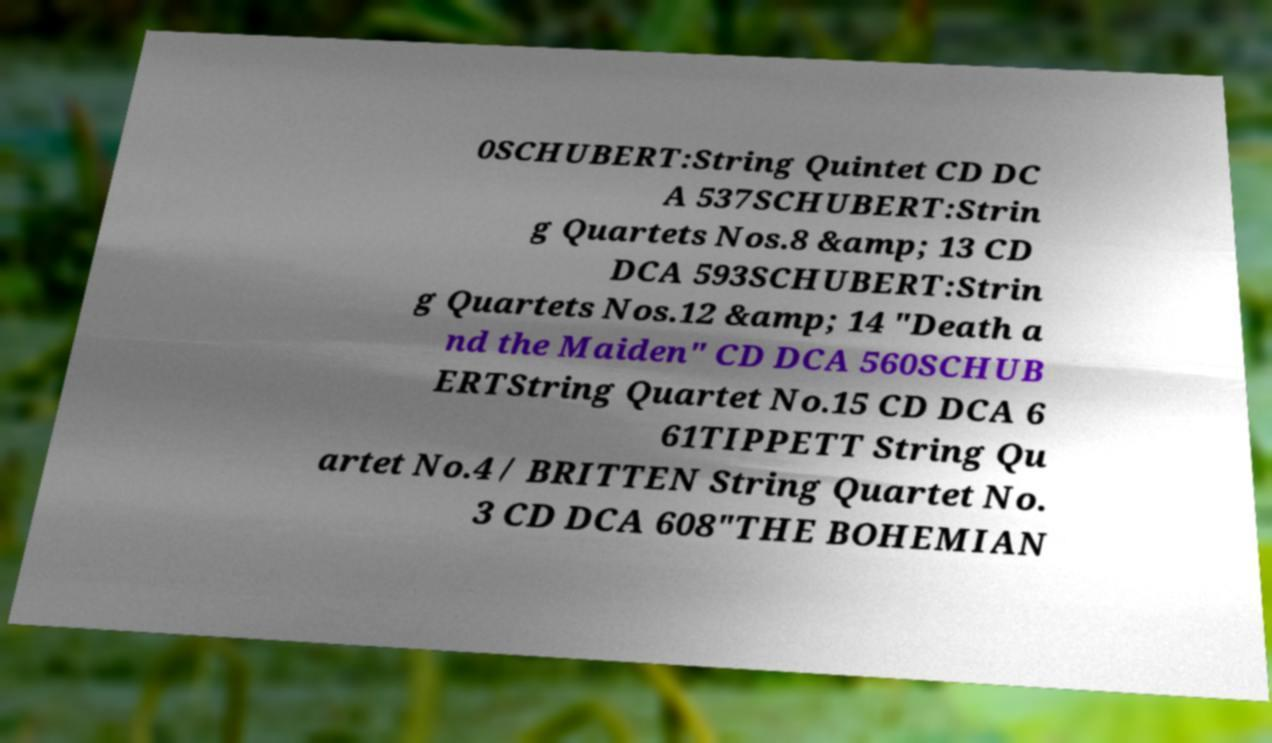Could you assist in decoding the text presented in this image and type it out clearly? 0SCHUBERT:String Quintet CD DC A 537SCHUBERT:Strin g Quartets Nos.8 &amp; 13 CD DCA 593SCHUBERT:Strin g Quartets Nos.12 &amp; 14 "Death a nd the Maiden" CD DCA 560SCHUB ERTString Quartet No.15 CD DCA 6 61TIPPETT String Qu artet No.4 / BRITTEN String Quartet No. 3 CD DCA 608"THE BOHEMIAN 